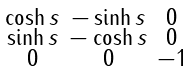Convert formula to latex. <formula><loc_0><loc_0><loc_500><loc_500>\begin{smallmatrix} \cosh s & - \sinh s & 0 \\ \sinh s & - \cosh s & 0 \\ 0 & 0 & - 1 \end{smallmatrix}</formula> 